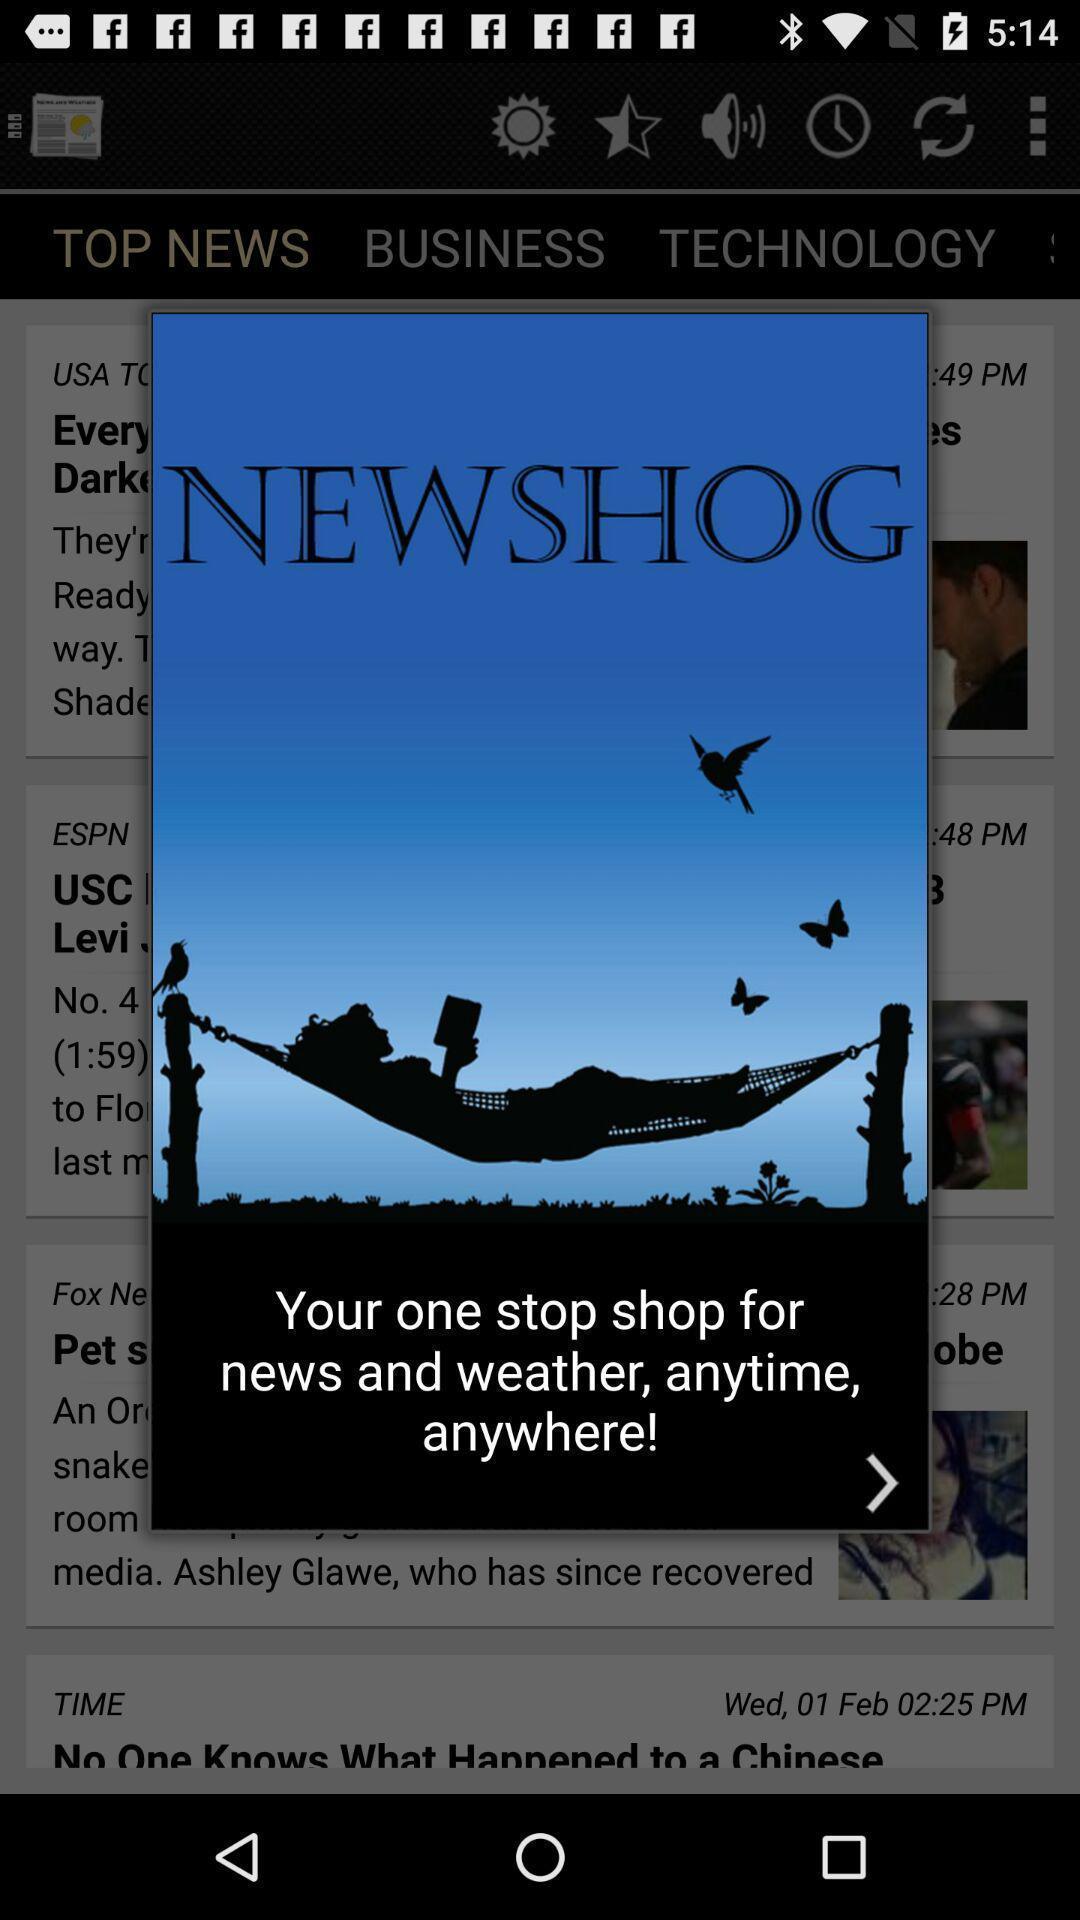Describe the visual elements of this screenshot. Screen shows about free news and weather app. 